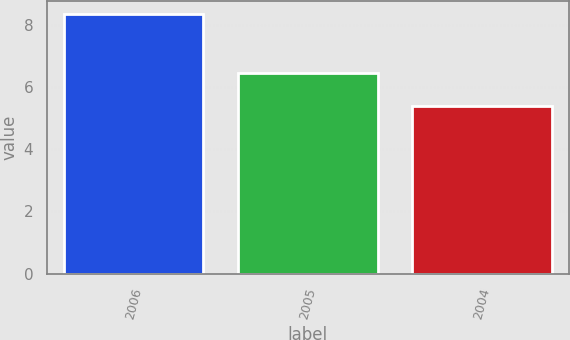<chart> <loc_0><loc_0><loc_500><loc_500><bar_chart><fcel>2006<fcel>2005<fcel>2004<nl><fcel>8.36<fcel>6.45<fcel>5.39<nl></chart> 